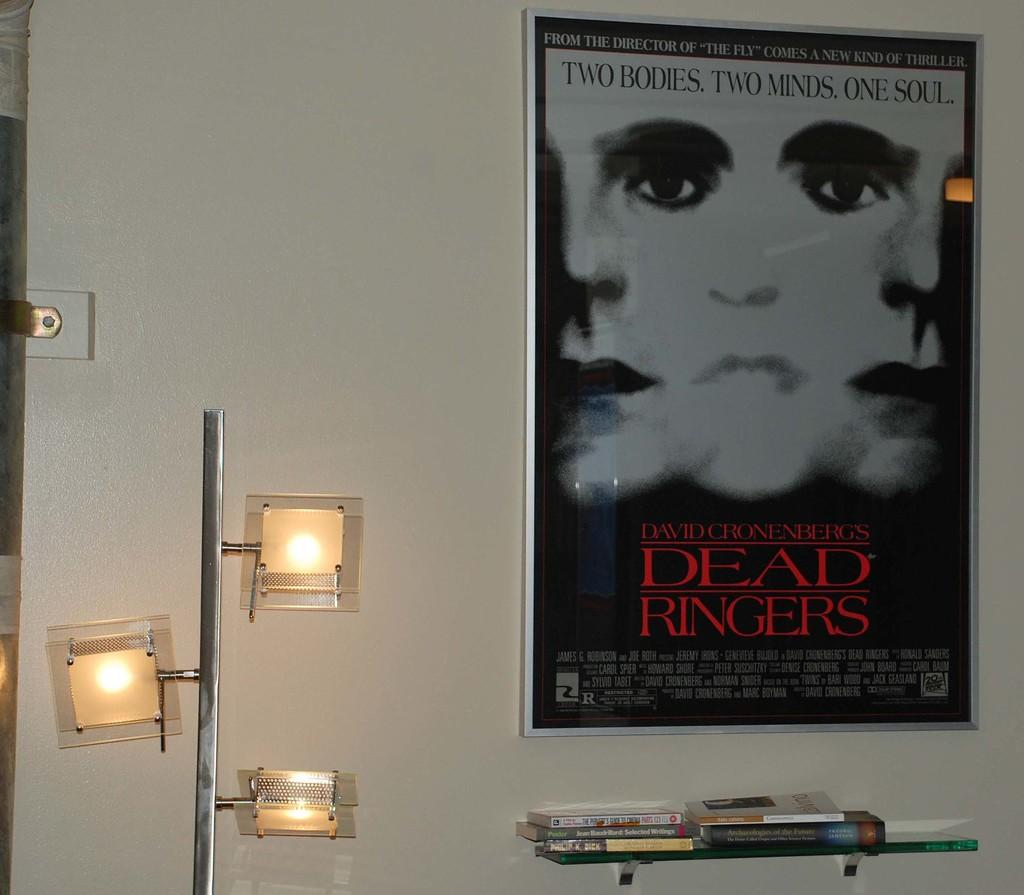<image>
Offer a succinct explanation of the picture presented. a room with a Dead Ringers poster on the wall 